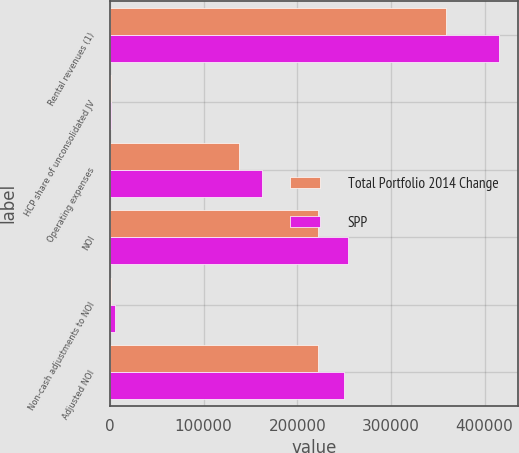Convert chart to OTSL. <chart><loc_0><loc_0><loc_500><loc_500><stacked_bar_chart><ecel><fcel>Rental revenues (1)<fcel>HCP share of unconsolidated JV<fcel>Operating expenses<fcel>NOI<fcel>Non-cash adjustments to NOI<fcel>Adjusted NOI<nl><fcel>Total Portfolio 2014 Change<fcel>358769<fcel>612<fcel>137411<fcel>222580<fcel>663<fcel>221917<nl><fcel>SPP<fcel>415351<fcel>612<fcel>162054<fcel>254555<fcel>4933<fcel>249622<nl></chart> 